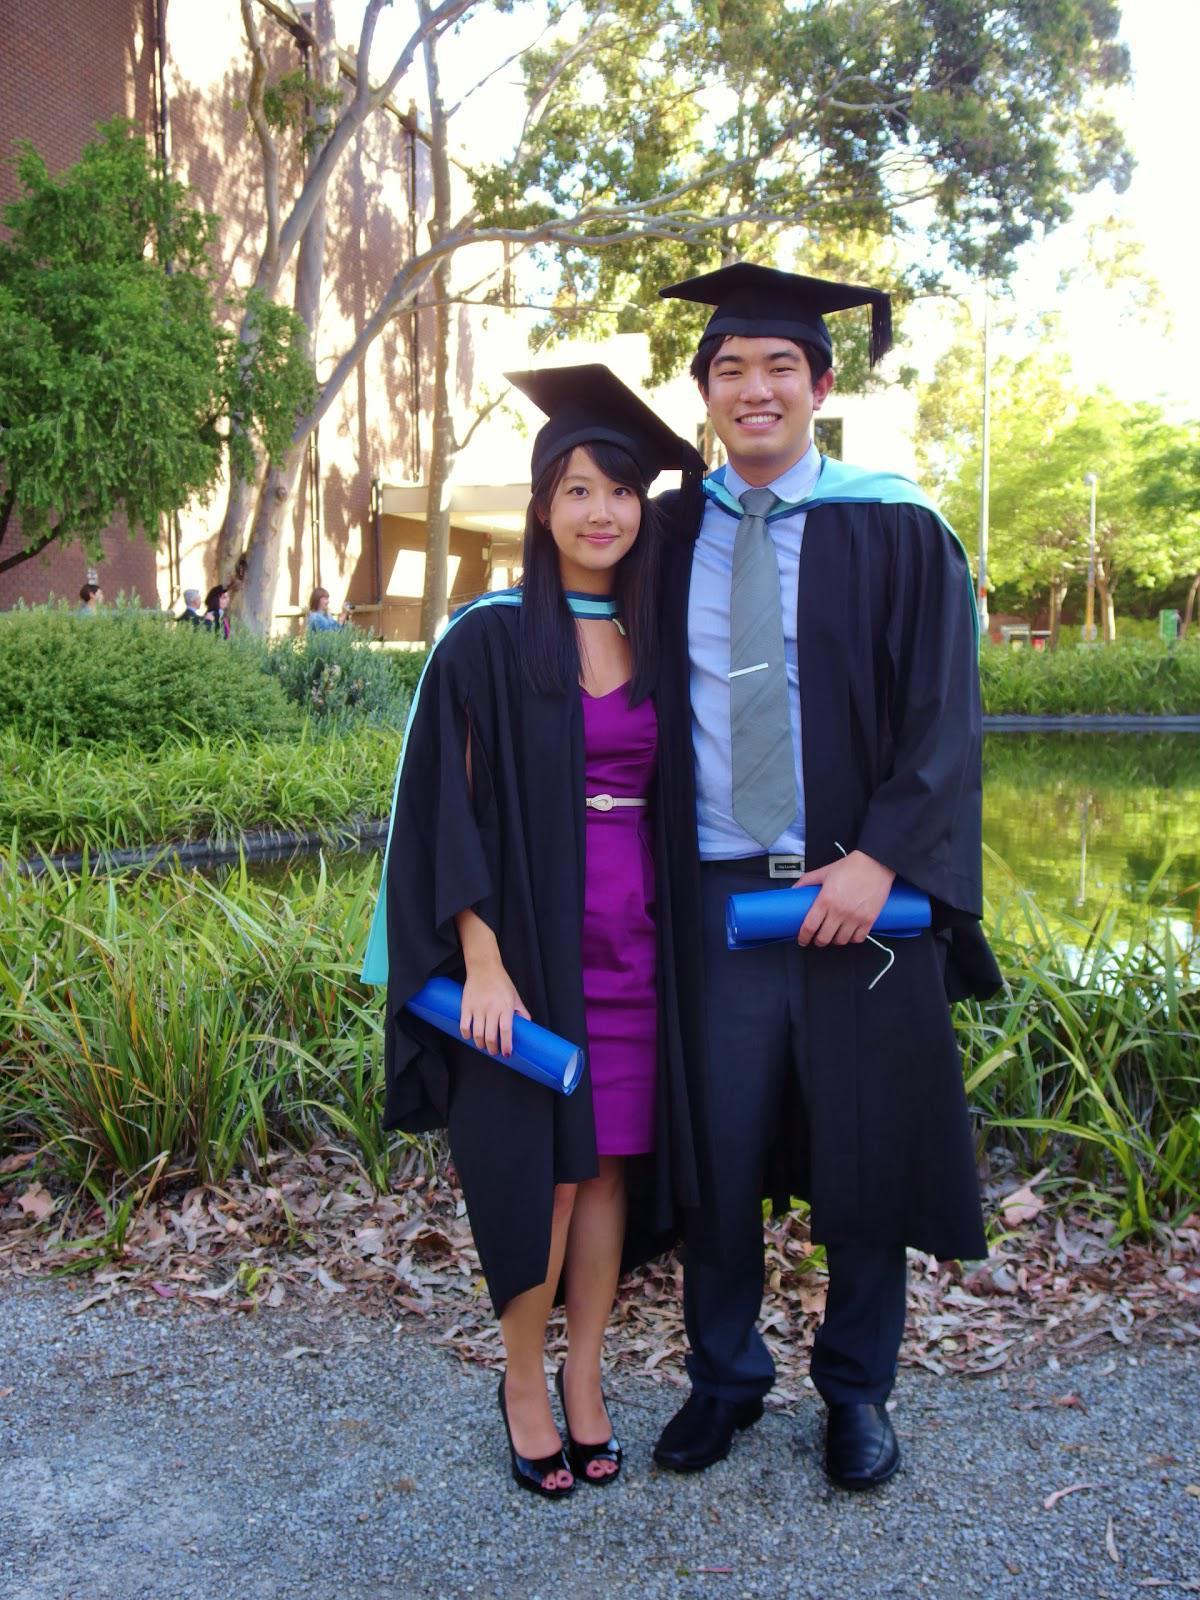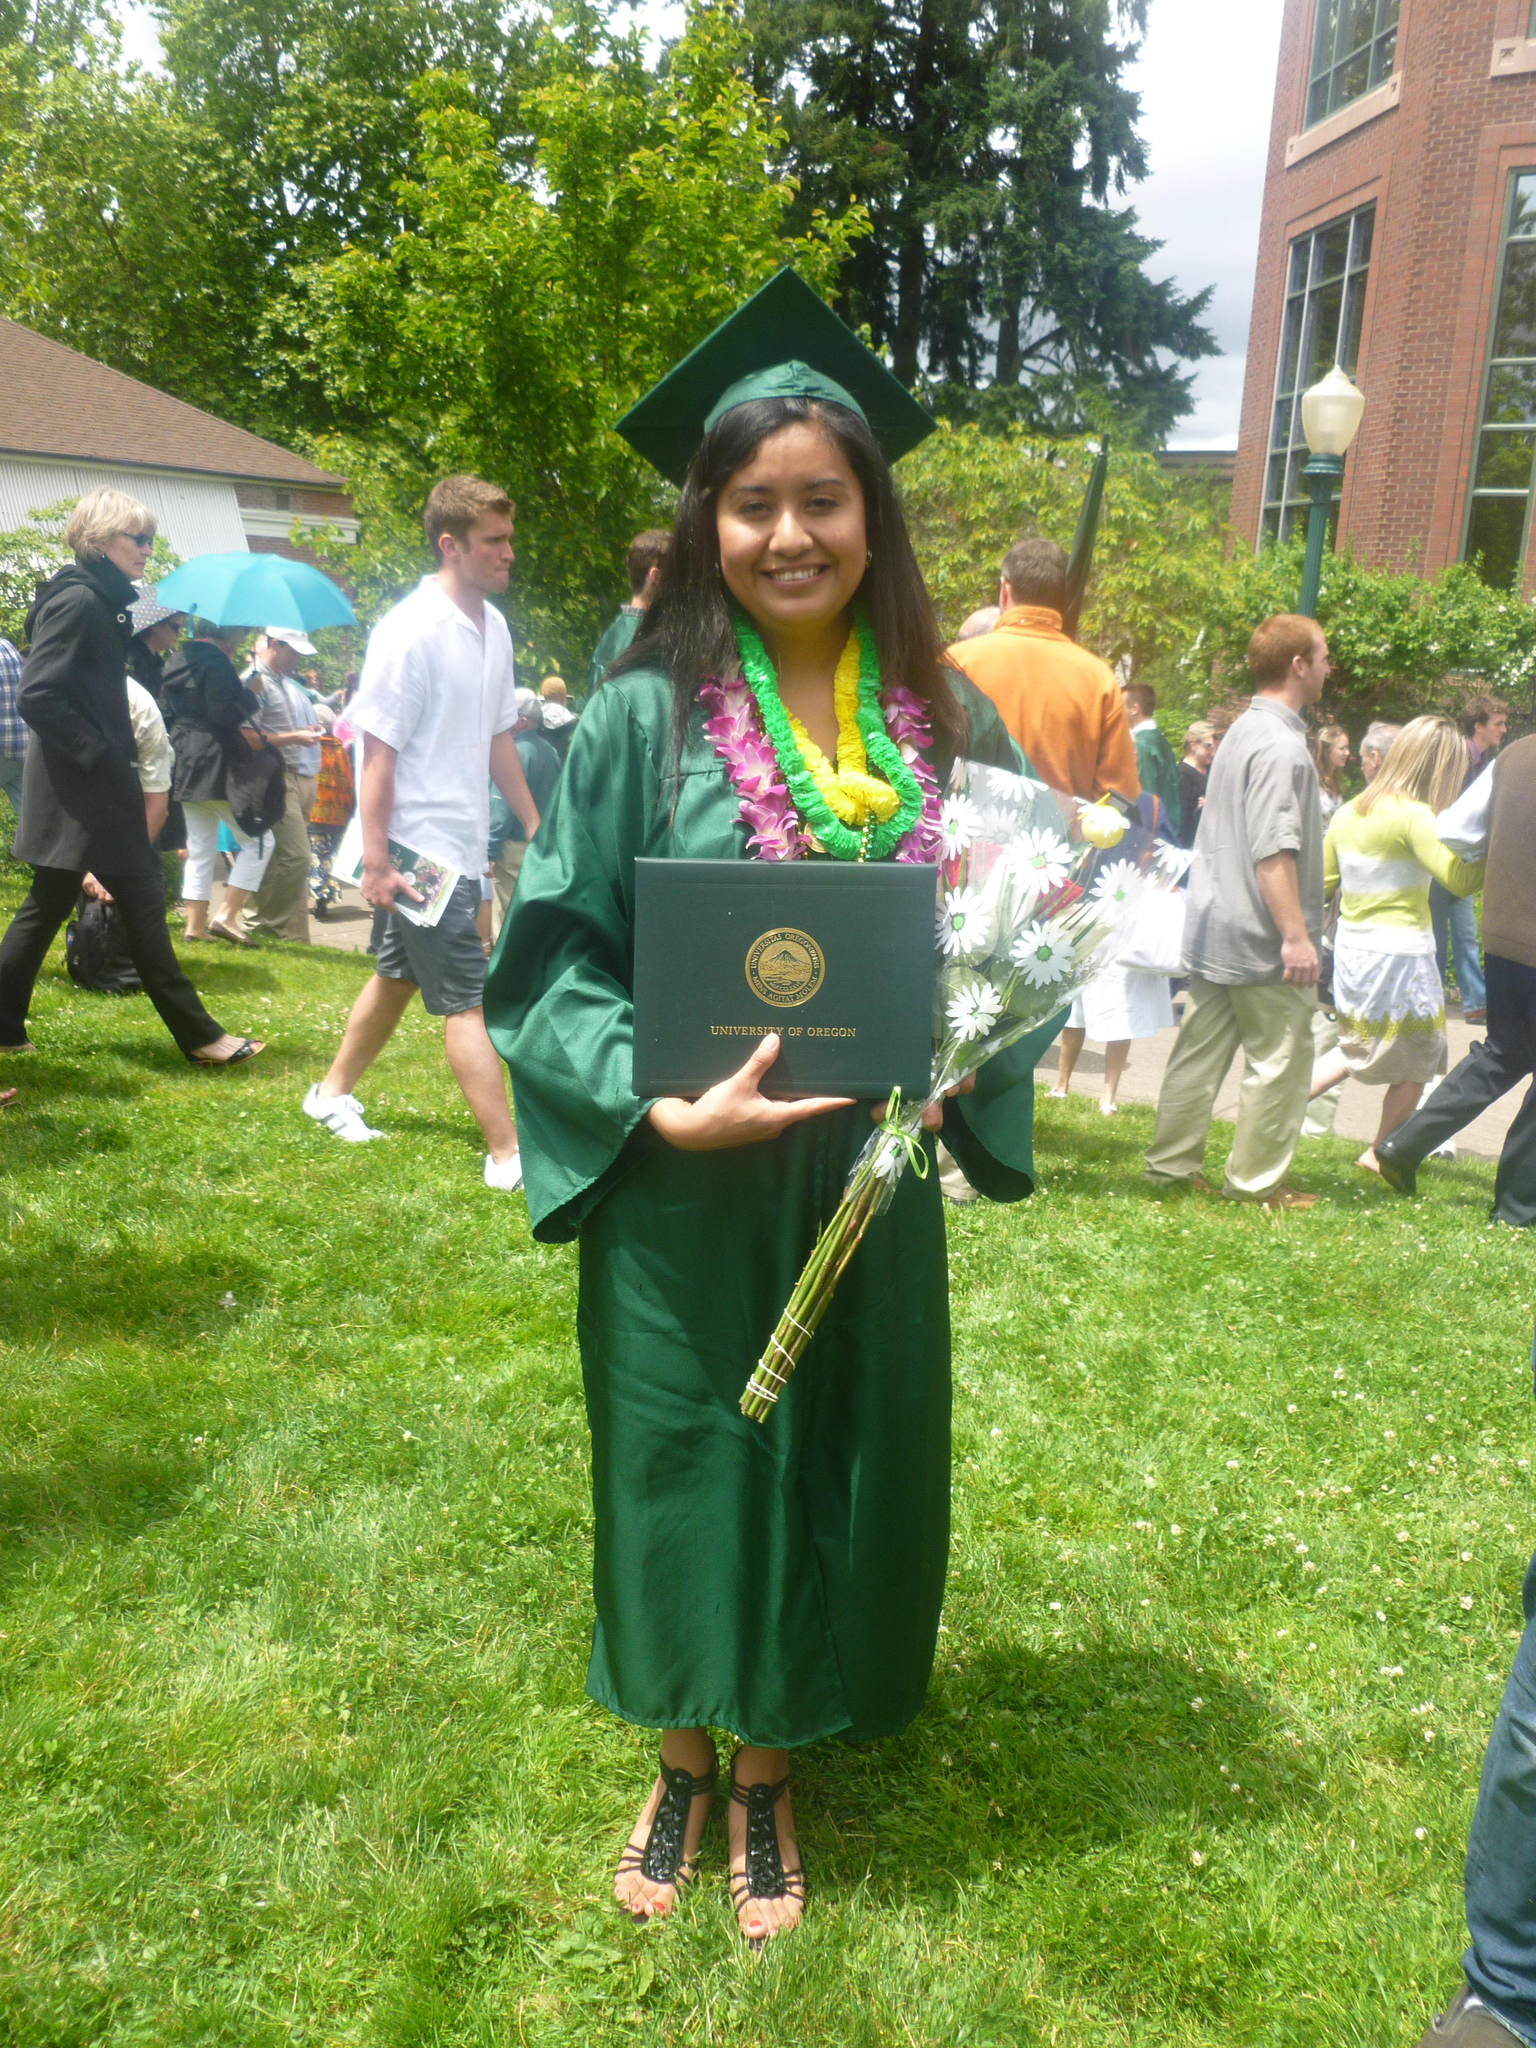The first image is the image on the left, the second image is the image on the right. Assess this claim about the two images: "There are total of three graduates.". Correct or not? Answer yes or no. Yes. 